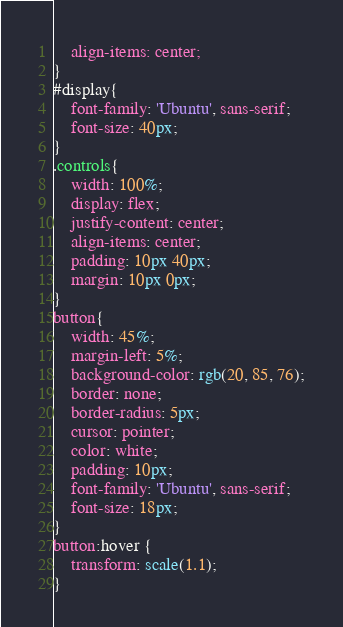<code> <loc_0><loc_0><loc_500><loc_500><_CSS_>    align-items: center;
}
#display{
    font-family: 'Ubuntu', sans-serif;
    font-size: 40px;
}
.controls{
    width: 100%;
    display: flex;
    justify-content: center;
    align-items: center;
    padding: 10px 40px;
    margin: 10px 0px;
}
button{
    width: 45%;
    margin-left: 5%;
    background-color: rgb(20, 85, 76);
    border: none;
    border-radius: 5px;
    cursor: pointer;
    color: white;
    padding: 10px;
    font-family: 'Ubuntu', sans-serif;
    font-size: 18px;
}
button:hover {
    transform: scale(1.1);
}

</code> 